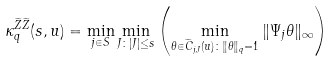<formula> <loc_0><loc_0><loc_500><loc_500>\kappa _ { q } ^ { \widetilde { Z } \widetilde { Z } } ( s , u ) = \min _ { j \in S } \min _ { J \colon | J | \leq s } \left ( \min _ { \theta \in \widetilde { C } _ { j , J } ( u ) \colon \| \theta \| _ { q } = 1 } \| \Psi _ { j } \theta \| _ { \infty } \right )</formula> 